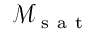Convert formula to latex. <formula><loc_0><loc_0><loc_500><loc_500>\mathcal { M } _ { s a t }</formula> 